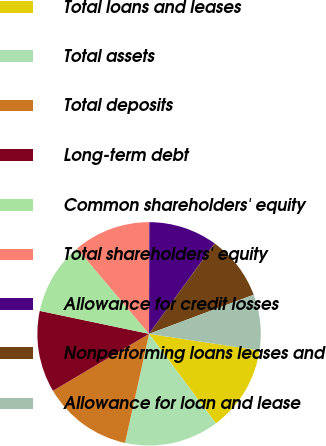<chart> <loc_0><loc_0><loc_500><loc_500><pie_chart><fcel>Total loans and leases<fcel>Total assets<fcel>Total deposits<fcel>Long-term debt<fcel>Common shareholders' equity<fcel>Total shareholders' equity<fcel>Allowance for credit losses<fcel>Nonperforming loans leases and<fcel>Allowance for loan and lease<nl><fcel>12.42%<fcel>13.66%<fcel>13.04%<fcel>11.8%<fcel>10.56%<fcel>11.18%<fcel>9.94%<fcel>9.32%<fcel>8.07%<nl></chart> 